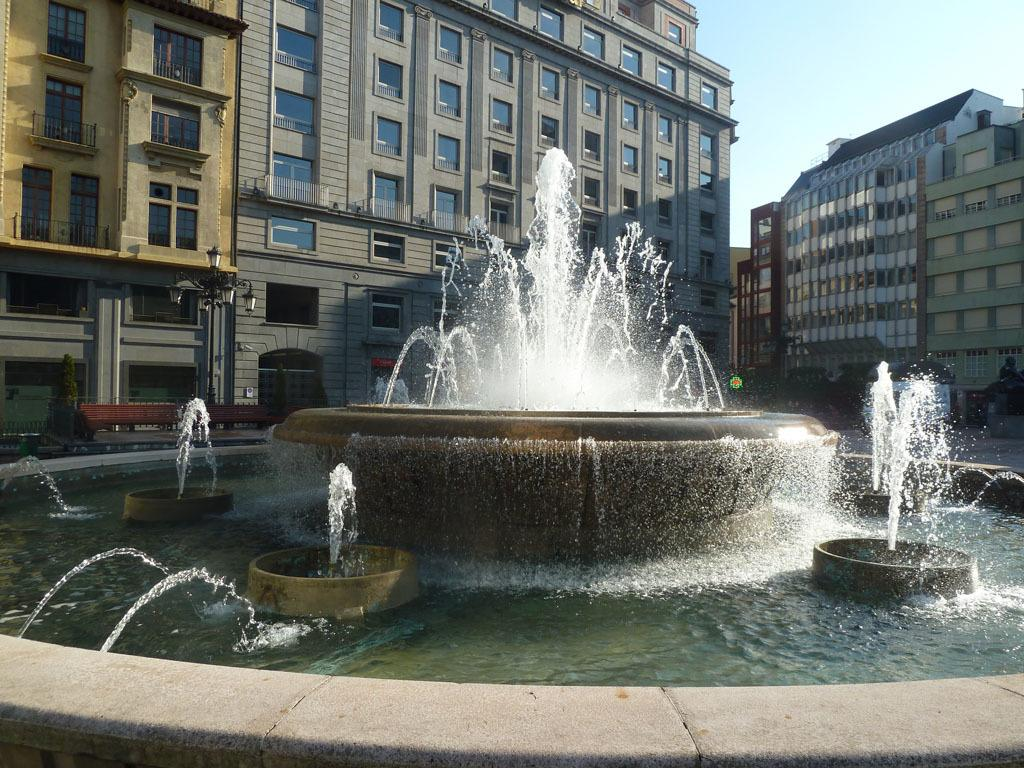What is the main subject in the center of the image? There is a water fountain in the center of the image. What can be seen in the background of the image? There are buildings in the background of the image. What other object is present in the image? There is a light pole in the image. Can you tell me how many bedrooms are visible in the image? There are no bedrooms present in the image. What type of flight is taking off in the image? There is no flight present in the image. 